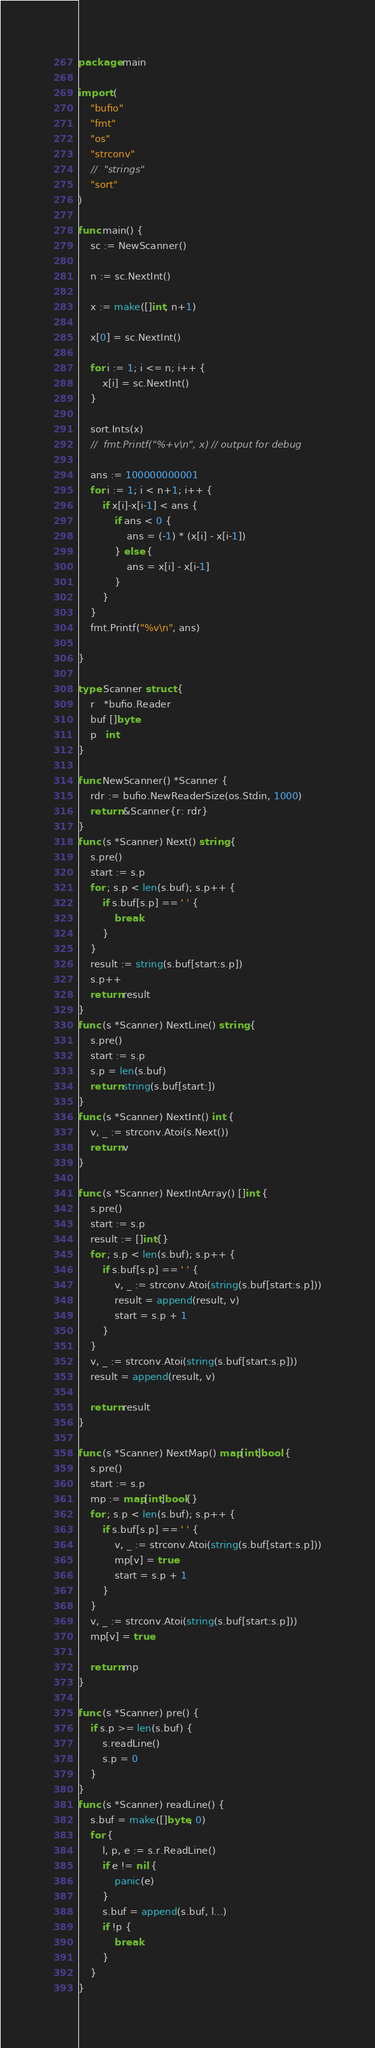<code> <loc_0><loc_0><loc_500><loc_500><_Go_>package main

import (
	"bufio"
	"fmt"
	"os"
	"strconv"
	//	"strings"
	"sort"
)

func main() {
	sc := NewScanner()

	n := sc.NextInt()

	x := make([]int, n+1)

	x[0] = sc.NextInt()

	for i := 1; i <= n; i++ {
		x[i] = sc.NextInt()
	}

	sort.Ints(x)
	//	fmt.Printf("%+v\n", x) // output for debug

	ans := 100000000001
	for i := 1; i < n+1; i++ {
		if x[i]-x[i-1] < ans {
			if ans < 0 {
				ans = (-1) * (x[i] - x[i-1])
			} else {
				ans = x[i] - x[i-1]
			}
		}
	}
	fmt.Printf("%v\n", ans)

}

type Scanner struct {
	r   *bufio.Reader
	buf []byte
	p   int
}

func NewScanner() *Scanner {
	rdr := bufio.NewReaderSize(os.Stdin, 1000)
	return &Scanner{r: rdr}
}
func (s *Scanner) Next() string {
	s.pre()
	start := s.p
	for ; s.p < len(s.buf); s.p++ {
		if s.buf[s.p] == ' ' {
			break
		}
	}
	result := string(s.buf[start:s.p])
	s.p++
	return result
}
func (s *Scanner) NextLine() string {
	s.pre()
	start := s.p
	s.p = len(s.buf)
	return string(s.buf[start:])
}
func (s *Scanner) NextInt() int {
	v, _ := strconv.Atoi(s.Next())
	return v
}

func (s *Scanner) NextIntArray() []int {
	s.pre()
	start := s.p
	result := []int{}
	for ; s.p < len(s.buf); s.p++ {
		if s.buf[s.p] == ' ' {
			v, _ := strconv.Atoi(string(s.buf[start:s.p]))
			result = append(result, v)
			start = s.p + 1
		}
	}
	v, _ := strconv.Atoi(string(s.buf[start:s.p]))
	result = append(result, v)

	return result
}

func (s *Scanner) NextMap() map[int]bool {
	s.pre()
	start := s.p
	mp := map[int]bool{}
	for ; s.p < len(s.buf); s.p++ {
		if s.buf[s.p] == ' ' {
			v, _ := strconv.Atoi(string(s.buf[start:s.p]))
			mp[v] = true
			start = s.p + 1
		}
	}
	v, _ := strconv.Atoi(string(s.buf[start:s.p]))
	mp[v] = true

	return mp
}

func (s *Scanner) pre() {
	if s.p >= len(s.buf) {
		s.readLine()
		s.p = 0
	}
}
func (s *Scanner) readLine() {
	s.buf = make([]byte, 0)
	for {
		l, p, e := s.r.ReadLine()
		if e != nil {
			panic(e)
		}
		s.buf = append(s.buf, l...)
		if !p {
			break
		}
	}
}
</code> 